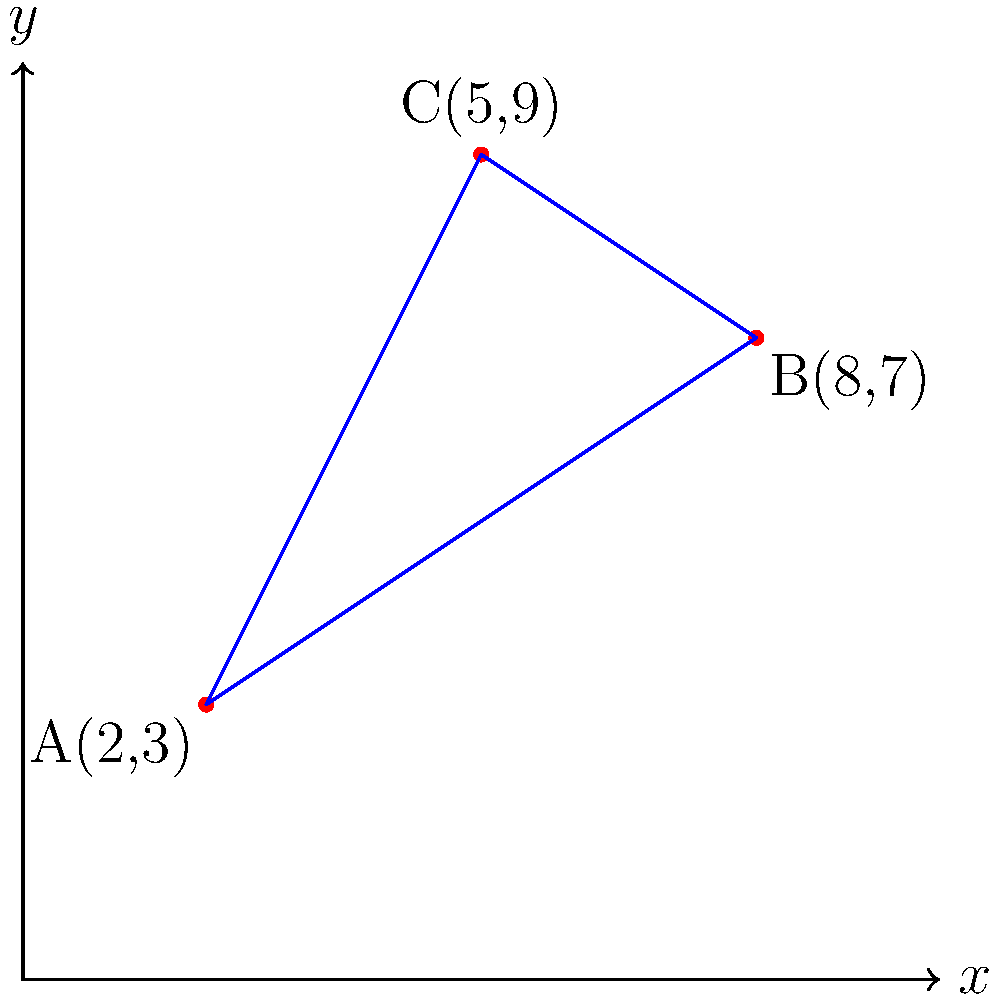As a cyclist rights advocate and former police officer, you're tasked with optimizing patrol routes between three police stations in a city. The stations are located at points A(2,3), B(8,7), and C(5,9) on a Cartesian plane, where each unit represents 1 km. What is the shortest total distance a cyclist would need to travel to visit all three stations exactly once and return to the starting point? To solve this problem, we need to calculate the distances between each pair of points and find the shortest route. Let's break it down step-by-step:

1) Calculate the distances between each pair of points using the distance formula:
   $d = \sqrt{(x_2-x_1)^2 + (y_2-y_1)^2}$

   AB: $\sqrt{(8-2)^2 + (7-3)^2} = \sqrt{36 + 16} = \sqrt{52} \approx 7.21$ km
   BC: $\sqrt{(5-8)^2 + (9-7)^2} = \sqrt{9 + 4} = \sqrt{13} \approx 3.61$ km
   CA: $\sqrt{(2-5)^2 + (3-9)^2} = \sqrt{9 + 36} = \sqrt{45} \approx 6.71$ km

2) The possible routes are:
   A-B-C-A
   A-C-B-A

3) Calculate the total distance for each route:
   A-B-C-A: 7.21 + 3.61 + 6.71 = 17.53 km
   A-C-B-A: 6.71 + 3.61 + 7.21 = 17.53 km

4) Both routes have the same total distance, so either can be chosen as the shortest route.

Therefore, the shortest total distance a cyclist would need to travel to visit all three stations exactly once and return to the starting point is approximately 17.53 km.
Answer: 17.53 km 